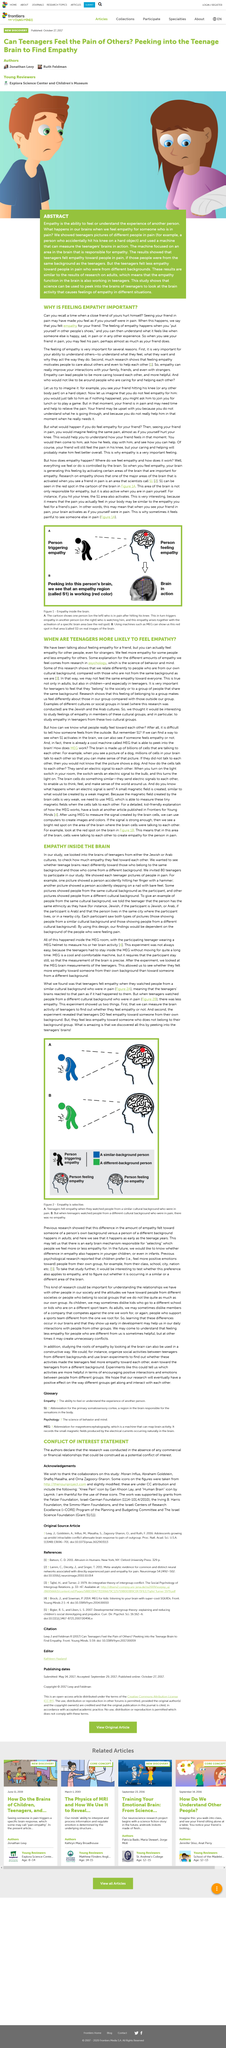Mention a couple of crucial points in this snapshot. Psychology is the scientific study of behavior and mind, which seeks to understand the emotions, thoughts, and motivations that underlie human and animal behavior. This experiment showed us two things. When one feels empathy, the brain activates areas of the brain that are important for empathy, generating the feeling. When an electrical signal is sent, a small magnetic field is created. The feeling of belonging to a group is what makes us feel differently about those in our group compared with those outside our group. 